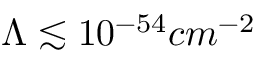<formula> <loc_0><loc_0><loc_500><loc_500>\Lambda \lesssim 1 0 ^ { - 5 4 } c m ^ { - 2 }</formula> 